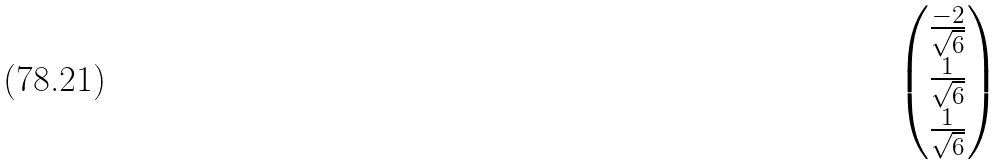<formula> <loc_0><loc_0><loc_500><loc_500>\begin{pmatrix} \frac { - 2 } { \sqrt { 6 } } \\ \frac { 1 } { \sqrt { 6 } } \\ \frac { 1 } { \sqrt { 6 } } \end{pmatrix}</formula> 